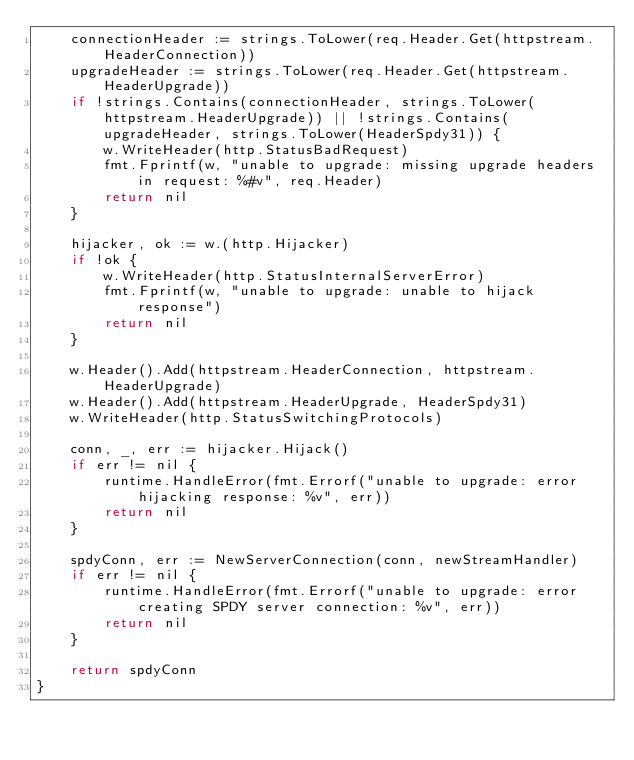Convert code to text. <code><loc_0><loc_0><loc_500><loc_500><_Go_>	connectionHeader := strings.ToLower(req.Header.Get(httpstream.HeaderConnection))
	upgradeHeader := strings.ToLower(req.Header.Get(httpstream.HeaderUpgrade))
	if !strings.Contains(connectionHeader, strings.ToLower(httpstream.HeaderUpgrade)) || !strings.Contains(upgradeHeader, strings.ToLower(HeaderSpdy31)) {
		w.WriteHeader(http.StatusBadRequest)
		fmt.Fprintf(w, "unable to upgrade: missing upgrade headers in request: %#v", req.Header)
		return nil
	}

	hijacker, ok := w.(http.Hijacker)
	if !ok {
		w.WriteHeader(http.StatusInternalServerError)
		fmt.Fprintf(w, "unable to upgrade: unable to hijack response")
		return nil
	}

	w.Header().Add(httpstream.HeaderConnection, httpstream.HeaderUpgrade)
	w.Header().Add(httpstream.HeaderUpgrade, HeaderSpdy31)
	w.WriteHeader(http.StatusSwitchingProtocols)

	conn, _, err := hijacker.Hijack()
	if err != nil {
		runtime.HandleError(fmt.Errorf("unable to upgrade: error hijacking response: %v", err))
		return nil
	}

	spdyConn, err := NewServerConnection(conn, newStreamHandler)
	if err != nil {
		runtime.HandleError(fmt.Errorf("unable to upgrade: error creating SPDY server connection: %v", err))
		return nil
	}

	return spdyConn
}
</code> 